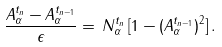<formula> <loc_0><loc_0><loc_500><loc_500>\frac { A ^ { t _ { n } } _ { \alpha } - A ^ { t _ { n - 1 } } _ { \alpha } } { \epsilon } = \, N ^ { t _ { n } } _ { \alpha } \, [ 1 - ( A ^ { t _ { n - 1 } } _ { \alpha } ) ^ { 2 } ] \, .</formula> 